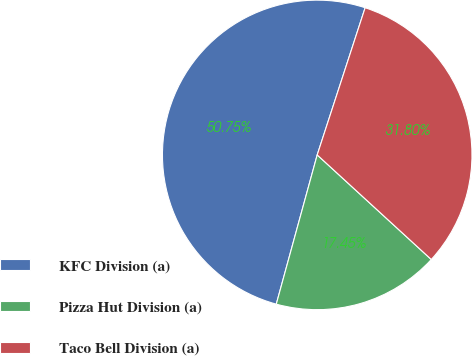Convert chart. <chart><loc_0><loc_0><loc_500><loc_500><pie_chart><fcel>KFC Division (a)<fcel>Pizza Hut Division (a)<fcel>Taco Bell Division (a)<nl><fcel>50.75%<fcel>17.45%<fcel>31.8%<nl></chart> 